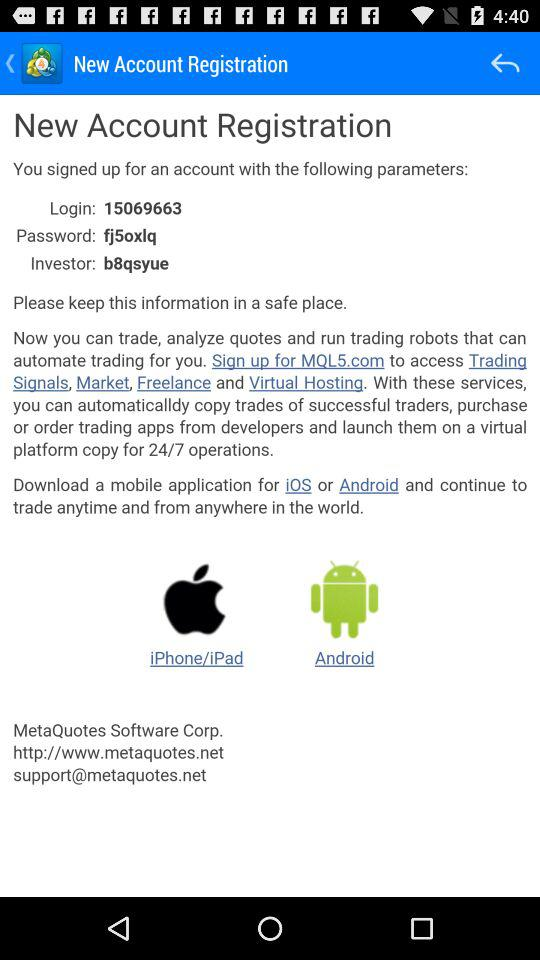For which platforms can we download the mobile application? You can download the mobile application for "iOS" and "Android". 